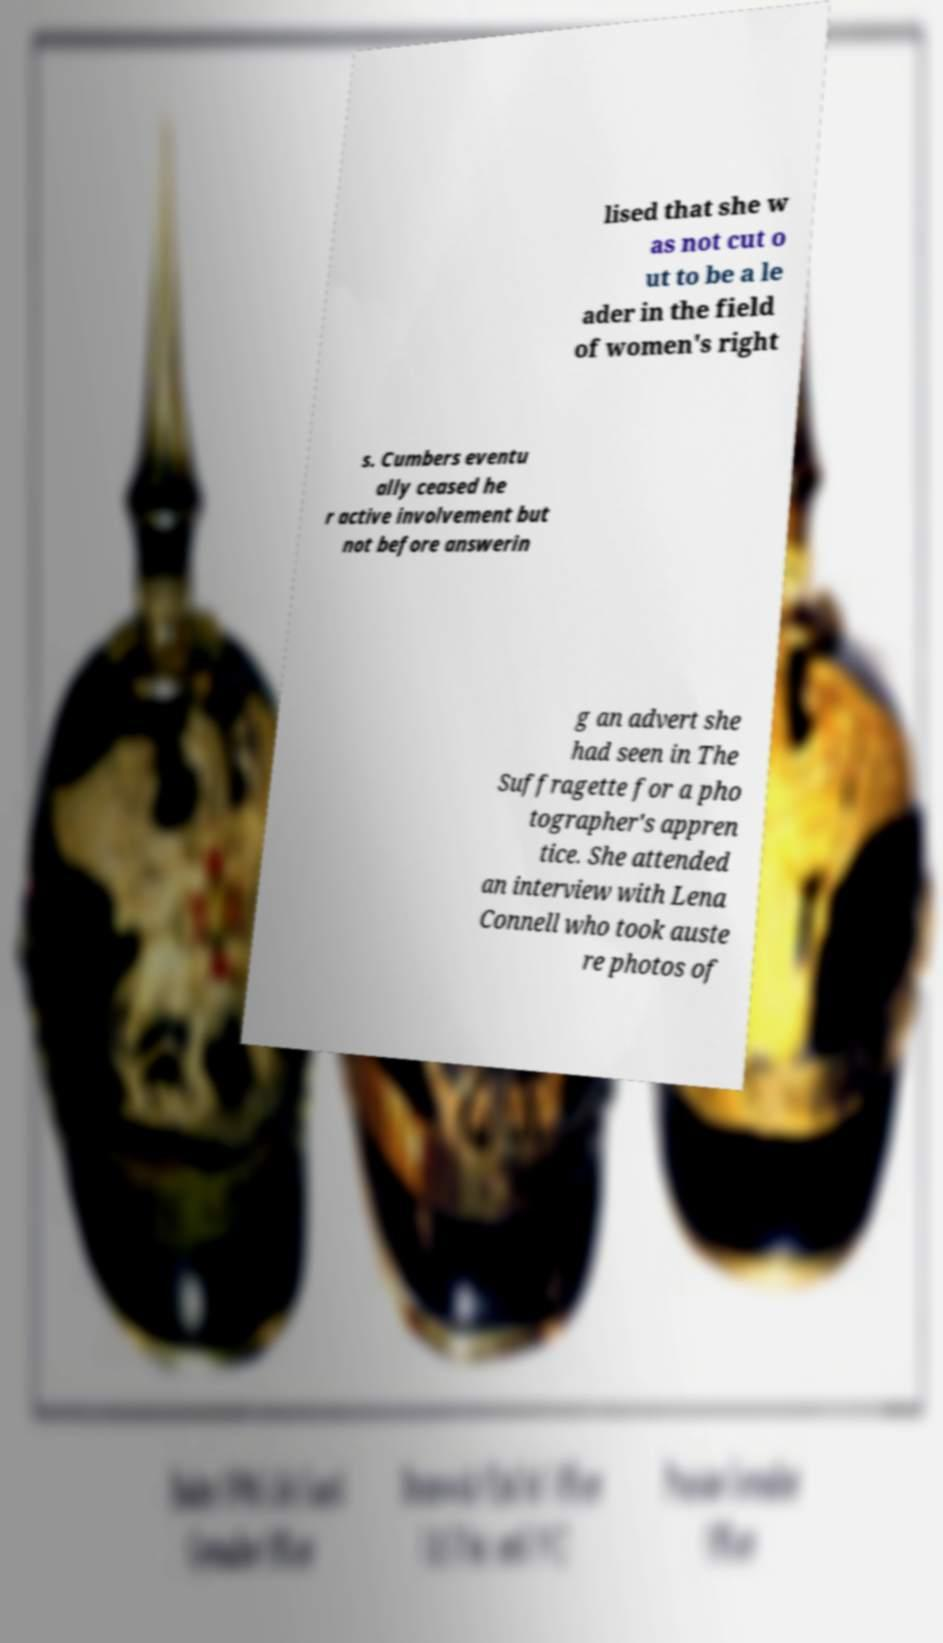Please read and relay the text visible in this image. What does it say? lised that she w as not cut o ut to be a le ader in the field of women's right s. Cumbers eventu ally ceased he r active involvement but not before answerin g an advert she had seen in The Suffragette for a pho tographer's appren tice. She attended an interview with Lena Connell who took auste re photos of 